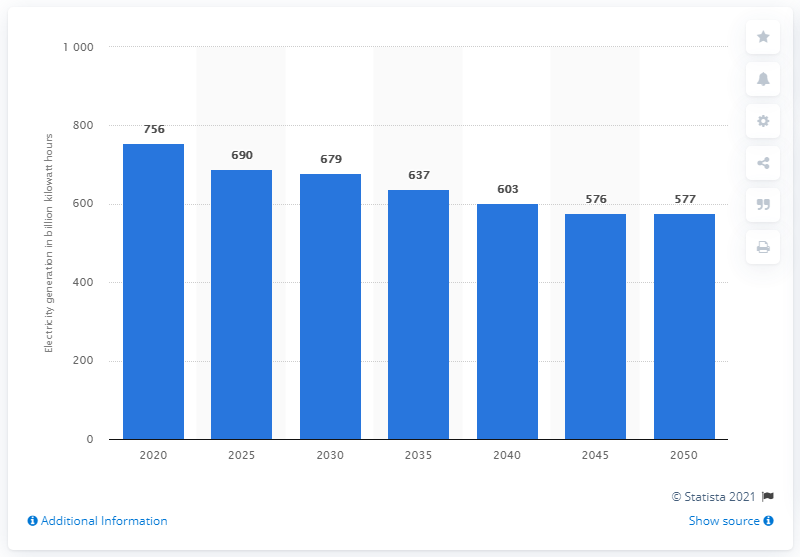Identify some key points in this picture. By the year 2050, the production of coal in the United States is projected to decrease to 577 billion kilowatt hours. The projected reduction in the production of coal in the U.S. by 2050 is expected to be 577%. In 2020, a total of 756 terawatt-hours of electricity was generated in the United States through the use of coal. 